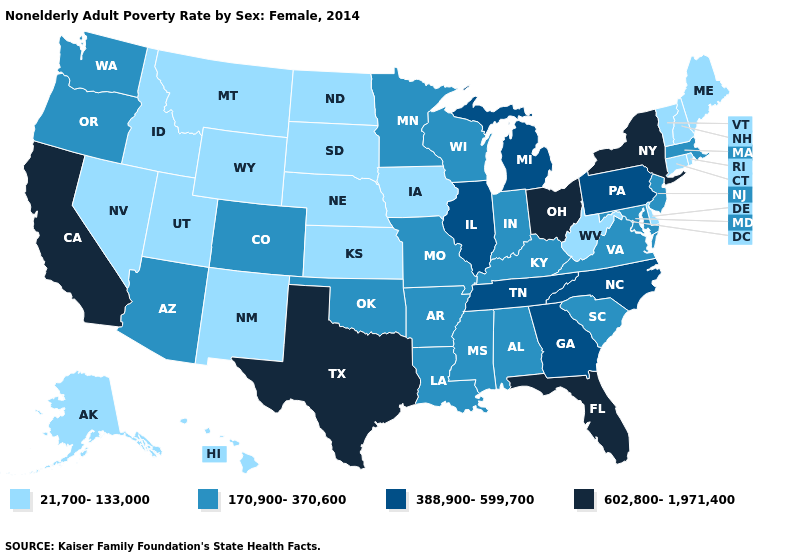What is the lowest value in states that border Idaho?
Give a very brief answer. 21,700-133,000. What is the value of Pennsylvania?
Quick response, please. 388,900-599,700. How many symbols are there in the legend?
Short answer required. 4. Does the map have missing data?
Quick response, please. No. What is the highest value in states that border Wisconsin?
Quick response, please. 388,900-599,700. What is the value of New Mexico?
Give a very brief answer. 21,700-133,000. What is the highest value in states that border Kansas?
Short answer required. 170,900-370,600. What is the highest value in the USA?
Short answer required. 602,800-1,971,400. Among the states that border Maryland , which have the highest value?
Keep it brief. Pennsylvania. What is the value of South Dakota?
Be succinct. 21,700-133,000. What is the lowest value in states that border Delaware?
Keep it brief. 170,900-370,600. What is the value of New Jersey?
Answer briefly. 170,900-370,600. Does New York have the lowest value in the Northeast?
Give a very brief answer. No. What is the value of Mississippi?
Give a very brief answer. 170,900-370,600. Which states have the highest value in the USA?
Concise answer only. California, Florida, New York, Ohio, Texas. 